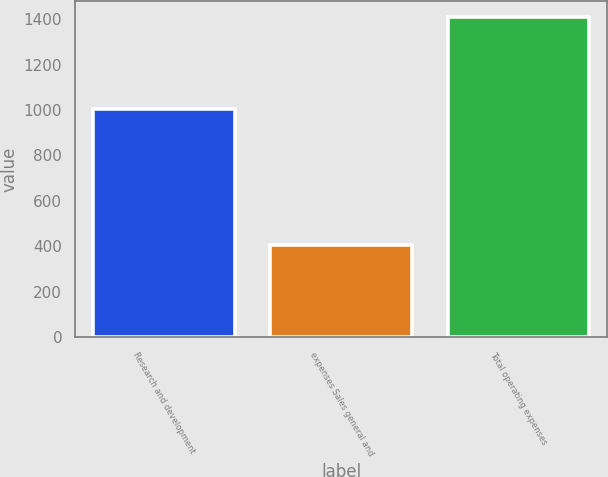<chart> <loc_0><loc_0><loc_500><loc_500><bar_chart><fcel>Research and development<fcel>expenses Sales general and<fcel>Total operating expenses<nl><fcel>1002.6<fcel>405.6<fcel>1408.2<nl></chart> 